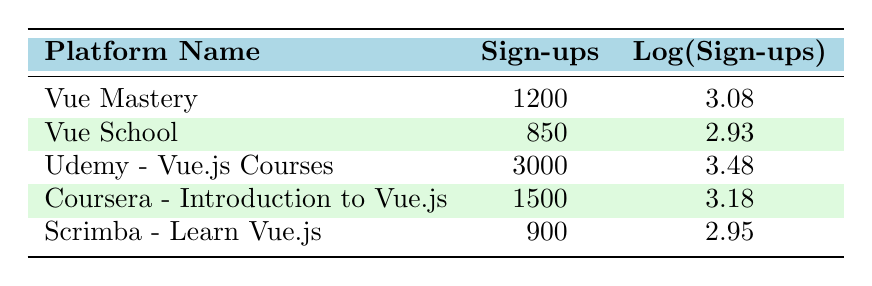What is the platform with the highest number of sign-ups? Udemy - Vue.js Courses has the highest number of sign-ups, which is 3000. This information can be found directly in the "Sign-ups" column of the table.
Answer: Udemy - Vue.js Courses What is the logarithmic value of sign-ups for Vue Mastery? The logarithmic value of sign-ups for Vue Mastery is 3.08, as indicated in the "Log(Sign-ups)" column of the table.
Answer: 3.08 What is the average number of sign-ups across all platforms? To find the average, sum the sign-ups: 1200 + 850 + 3000 + 1500 + 900 = 6450. Divide by the number of platforms (5): 6450 / 5 = 1290.
Answer: 1290 Is the number of sign-ups greater for Coursera than for Vue School? Coursera has 1500 sign-ups and Vue School has 850. Since 1500 is greater than 850, the statement is true.
Answer: Yes Which platform has a logarithmic value of sign-ups greater than 3? The platforms with a logarithmic value greater than 3 are Udemy - Vue.js Courses (3.48), Coursera - Introduction to Vue.js (3.18), and Vue Mastery (3.08). This can be determined by comparing the values in the "Log(Sign-ups)" column.
Answer: Udemy - Vue.js Courses, Coursera - Introduction to Vue.js, Vue Mastery What is the difference in sign-ups between Udemy - Vue.js Courses and Scrimba? Udemy - Vue.js Courses has 3000 sign-ups and Scrimba has 900. The difference is calculated by subtracting Scrimba's sign-ups from Udemy's: 3000 - 900 = 2100.
Answer: 2100 Does Vue School have more sign-ups than Scrimba? Vue School has 850 sign-ups and Scrimba has 900. Since 850 is less than 900, the statement is false.
Answer: No What is the total number of sign-ups for the three platforms with the lowest sign-ups? The platforms with the lowest sign-ups are Vue School (850), Scrimba (900), and Vue Mastery (1200). The total sign-ups are calculated by summing these values: 850 + 900 + 1200 = 2950.
Answer: 2950 Which platform has the second highest number of sign-ups? The platforms listed in descending order of sign-ups are: Udemy - Vue.js Courses (3000), Coursera - Introduction to Vue.js (1500), Vue Mastery (1200), Scrimba (900), and Vue School (850). Thus, Coursera - Introduction to Vue.js is the second highest.
Answer: Coursera - Introduction to Vue.js 